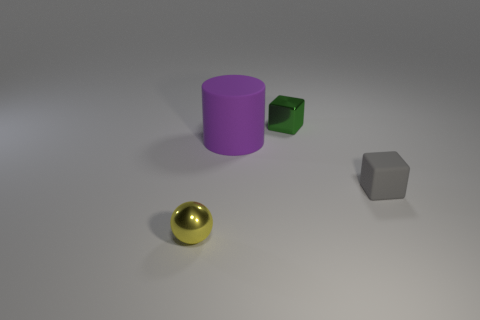Add 1 large yellow shiny cylinders. How many objects exist? 5 Subtract all cylinders. How many objects are left? 3 Add 3 tiny yellow shiny spheres. How many tiny yellow shiny spheres are left? 4 Add 4 balls. How many balls exist? 5 Subtract 0 gray cylinders. How many objects are left? 4 Subtract all green metallic blocks. Subtract all purple cylinders. How many objects are left? 2 